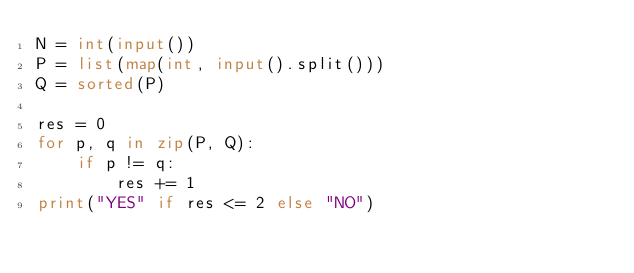Convert code to text. <code><loc_0><loc_0><loc_500><loc_500><_Python_>N = int(input())
P = list(map(int, input().split()))
Q = sorted(P)

res = 0
for p, q in zip(P, Q):
    if p != q:
        res += 1
print("YES" if res <= 2 else "NO")
</code> 